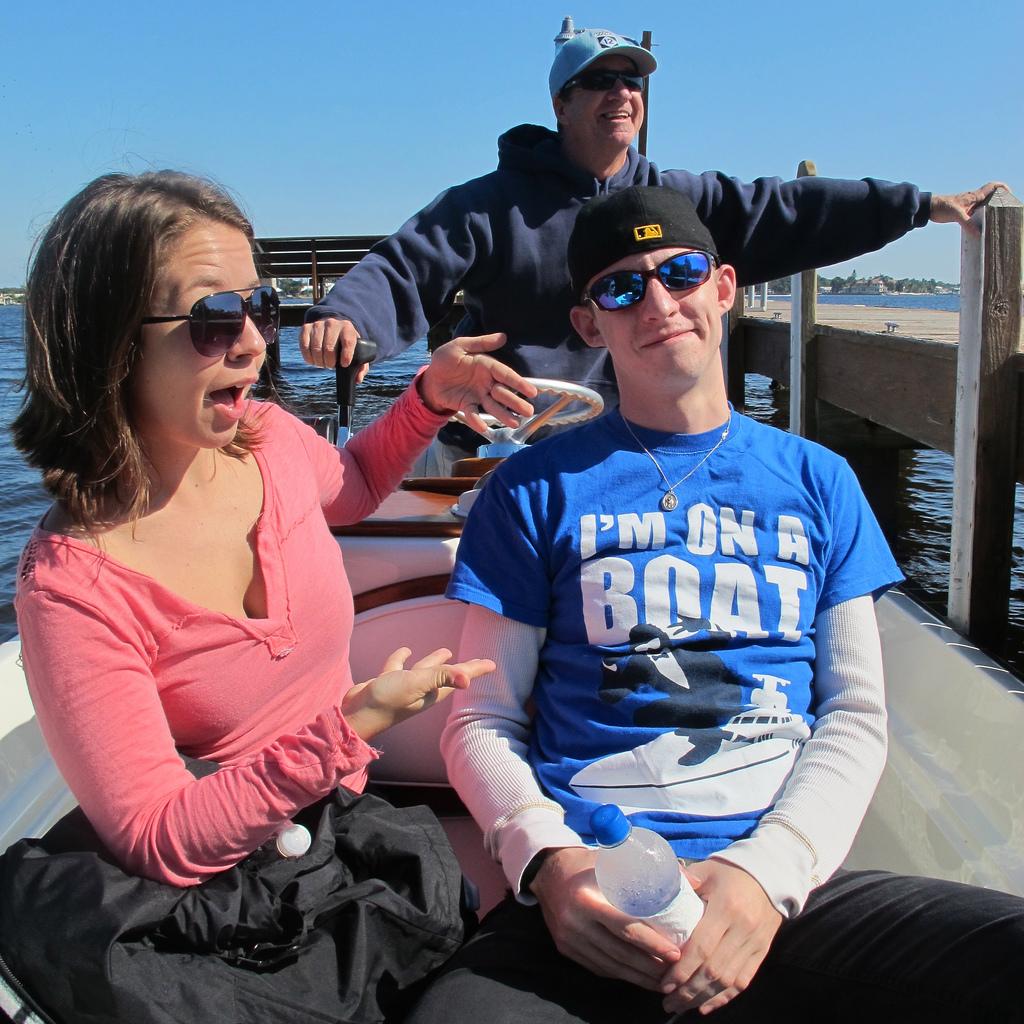What is written on teh blue shirt?
Your answer should be compact. I'm on a boat. 